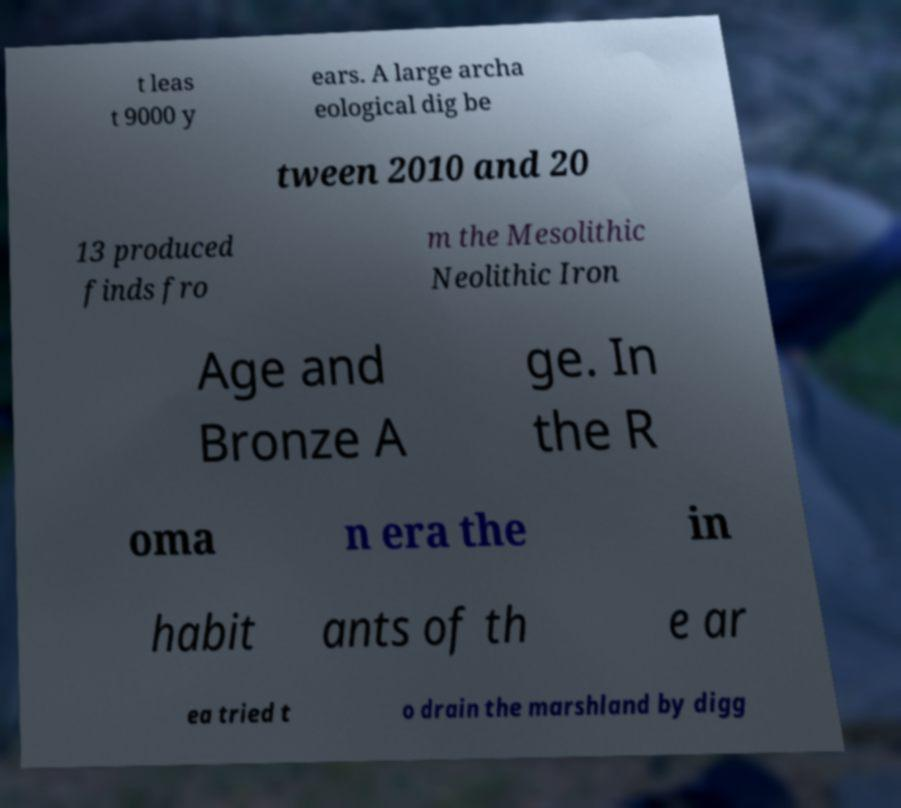Could you extract and type out the text from this image? t leas t 9000 y ears. A large archa eological dig be tween 2010 and 20 13 produced finds fro m the Mesolithic Neolithic Iron Age and Bronze A ge. In the R oma n era the in habit ants of th e ar ea tried t o drain the marshland by digg 